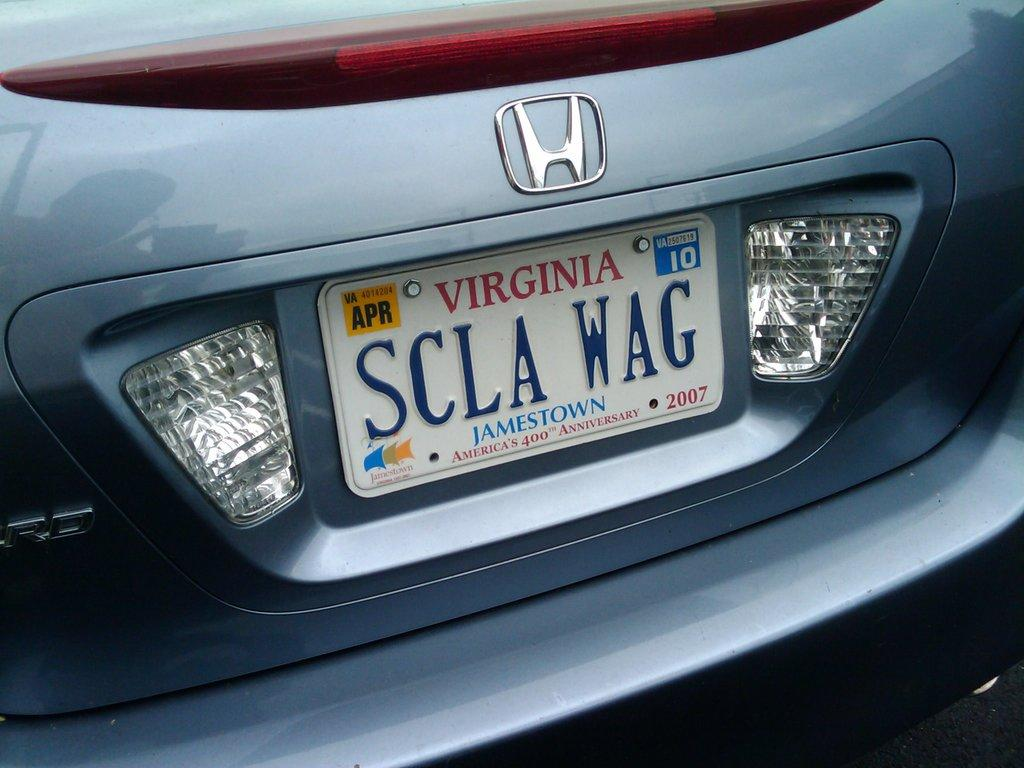<image>
Provide a brief description of the given image. A blue Honda has a Virginia license plate that reads SCLA WAG. 